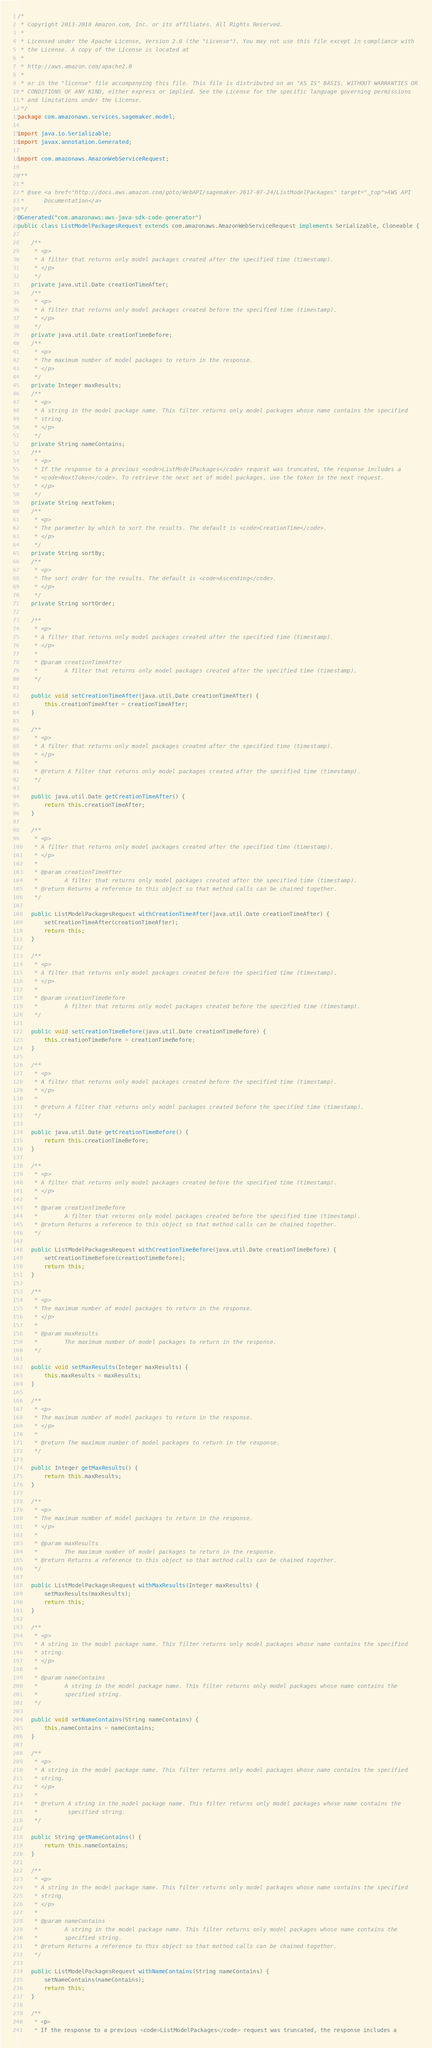<code> <loc_0><loc_0><loc_500><loc_500><_Java_>/*
 * Copyright 2013-2018 Amazon.com, Inc. or its affiliates. All Rights Reserved.
 * 
 * Licensed under the Apache License, Version 2.0 (the "License"). You may not use this file except in compliance with
 * the License. A copy of the License is located at
 * 
 * http://aws.amazon.com/apache2.0
 * 
 * or in the "license" file accompanying this file. This file is distributed on an "AS IS" BASIS, WITHOUT WARRANTIES OR
 * CONDITIONS OF ANY KIND, either express or implied. See the License for the specific language governing permissions
 * and limitations under the License.
 */
package com.amazonaws.services.sagemaker.model;

import java.io.Serializable;
import javax.annotation.Generated;

import com.amazonaws.AmazonWebServiceRequest;

/**
 * 
 * @see <a href="http://docs.aws.amazon.com/goto/WebAPI/sagemaker-2017-07-24/ListModelPackages" target="_top">AWS API
 *      Documentation</a>
 */
@Generated("com.amazonaws:aws-java-sdk-code-generator")
public class ListModelPackagesRequest extends com.amazonaws.AmazonWebServiceRequest implements Serializable, Cloneable {

    /**
     * <p>
     * A filter that returns only model packages created after the specified time (timestamp).
     * </p>
     */
    private java.util.Date creationTimeAfter;
    /**
     * <p>
     * A filter that returns only model packages created before the specified time (timestamp).
     * </p>
     */
    private java.util.Date creationTimeBefore;
    /**
     * <p>
     * The maximum number of model packages to return in the response.
     * </p>
     */
    private Integer maxResults;
    /**
     * <p>
     * A string in the model package name. This filter returns only model packages whose name contains the specified
     * string.
     * </p>
     */
    private String nameContains;
    /**
     * <p>
     * If the response to a previous <code>ListModelPackages</code> request was truncated, the response includes a
     * <code>NextToken</code>. To retrieve the next set of model packages, use the token in the next request.
     * </p>
     */
    private String nextToken;
    /**
     * <p>
     * The parameter by which to sort the results. The default is <code>CreationTime</code>.
     * </p>
     */
    private String sortBy;
    /**
     * <p>
     * The sort order for the results. The default is <code>Ascending</code>.
     * </p>
     */
    private String sortOrder;

    /**
     * <p>
     * A filter that returns only model packages created after the specified time (timestamp).
     * </p>
     * 
     * @param creationTimeAfter
     *        A filter that returns only model packages created after the specified time (timestamp).
     */

    public void setCreationTimeAfter(java.util.Date creationTimeAfter) {
        this.creationTimeAfter = creationTimeAfter;
    }

    /**
     * <p>
     * A filter that returns only model packages created after the specified time (timestamp).
     * </p>
     * 
     * @return A filter that returns only model packages created after the specified time (timestamp).
     */

    public java.util.Date getCreationTimeAfter() {
        return this.creationTimeAfter;
    }

    /**
     * <p>
     * A filter that returns only model packages created after the specified time (timestamp).
     * </p>
     * 
     * @param creationTimeAfter
     *        A filter that returns only model packages created after the specified time (timestamp).
     * @return Returns a reference to this object so that method calls can be chained together.
     */

    public ListModelPackagesRequest withCreationTimeAfter(java.util.Date creationTimeAfter) {
        setCreationTimeAfter(creationTimeAfter);
        return this;
    }

    /**
     * <p>
     * A filter that returns only model packages created before the specified time (timestamp).
     * </p>
     * 
     * @param creationTimeBefore
     *        A filter that returns only model packages created before the specified time (timestamp).
     */

    public void setCreationTimeBefore(java.util.Date creationTimeBefore) {
        this.creationTimeBefore = creationTimeBefore;
    }

    /**
     * <p>
     * A filter that returns only model packages created before the specified time (timestamp).
     * </p>
     * 
     * @return A filter that returns only model packages created before the specified time (timestamp).
     */

    public java.util.Date getCreationTimeBefore() {
        return this.creationTimeBefore;
    }

    /**
     * <p>
     * A filter that returns only model packages created before the specified time (timestamp).
     * </p>
     * 
     * @param creationTimeBefore
     *        A filter that returns only model packages created before the specified time (timestamp).
     * @return Returns a reference to this object so that method calls can be chained together.
     */

    public ListModelPackagesRequest withCreationTimeBefore(java.util.Date creationTimeBefore) {
        setCreationTimeBefore(creationTimeBefore);
        return this;
    }

    /**
     * <p>
     * The maximum number of model packages to return in the response.
     * </p>
     * 
     * @param maxResults
     *        The maximum number of model packages to return in the response.
     */

    public void setMaxResults(Integer maxResults) {
        this.maxResults = maxResults;
    }

    /**
     * <p>
     * The maximum number of model packages to return in the response.
     * </p>
     * 
     * @return The maximum number of model packages to return in the response.
     */

    public Integer getMaxResults() {
        return this.maxResults;
    }

    /**
     * <p>
     * The maximum number of model packages to return in the response.
     * </p>
     * 
     * @param maxResults
     *        The maximum number of model packages to return in the response.
     * @return Returns a reference to this object so that method calls can be chained together.
     */

    public ListModelPackagesRequest withMaxResults(Integer maxResults) {
        setMaxResults(maxResults);
        return this;
    }

    /**
     * <p>
     * A string in the model package name. This filter returns only model packages whose name contains the specified
     * string.
     * </p>
     * 
     * @param nameContains
     *        A string in the model package name. This filter returns only model packages whose name contains the
     *        specified string.
     */

    public void setNameContains(String nameContains) {
        this.nameContains = nameContains;
    }

    /**
     * <p>
     * A string in the model package name. This filter returns only model packages whose name contains the specified
     * string.
     * </p>
     * 
     * @return A string in the model package name. This filter returns only model packages whose name contains the
     *         specified string.
     */

    public String getNameContains() {
        return this.nameContains;
    }

    /**
     * <p>
     * A string in the model package name. This filter returns only model packages whose name contains the specified
     * string.
     * </p>
     * 
     * @param nameContains
     *        A string in the model package name. This filter returns only model packages whose name contains the
     *        specified string.
     * @return Returns a reference to this object so that method calls can be chained together.
     */

    public ListModelPackagesRequest withNameContains(String nameContains) {
        setNameContains(nameContains);
        return this;
    }

    /**
     * <p>
     * If the response to a previous <code>ListModelPackages</code> request was truncated, the response includes a</code> 